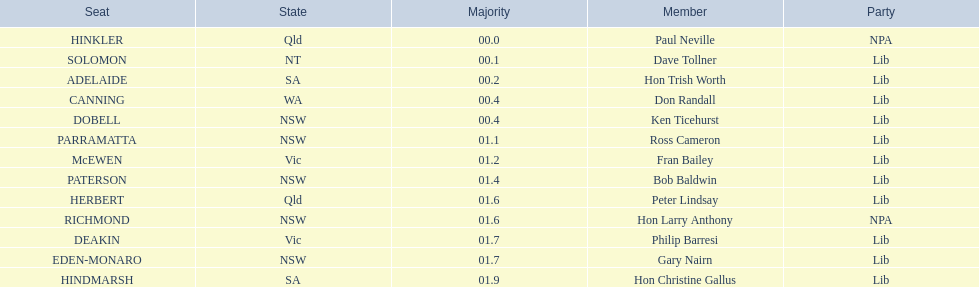Which seats are included in the australian electoral system? HINKLER, SOLOMON, ADELAIDE, CANNING, DOBELL, PARRAMATTA, McEWEN, PATERSON, HERBERT, RICHMOND, DEAKIN, EDEN-MONARO, HINDMARSH. What were the majority numbers for hindmarsh and hinkler? HINKLER, HINDMARSH. What is the discrepancy in the voting majority between these two seats? 01.9. 